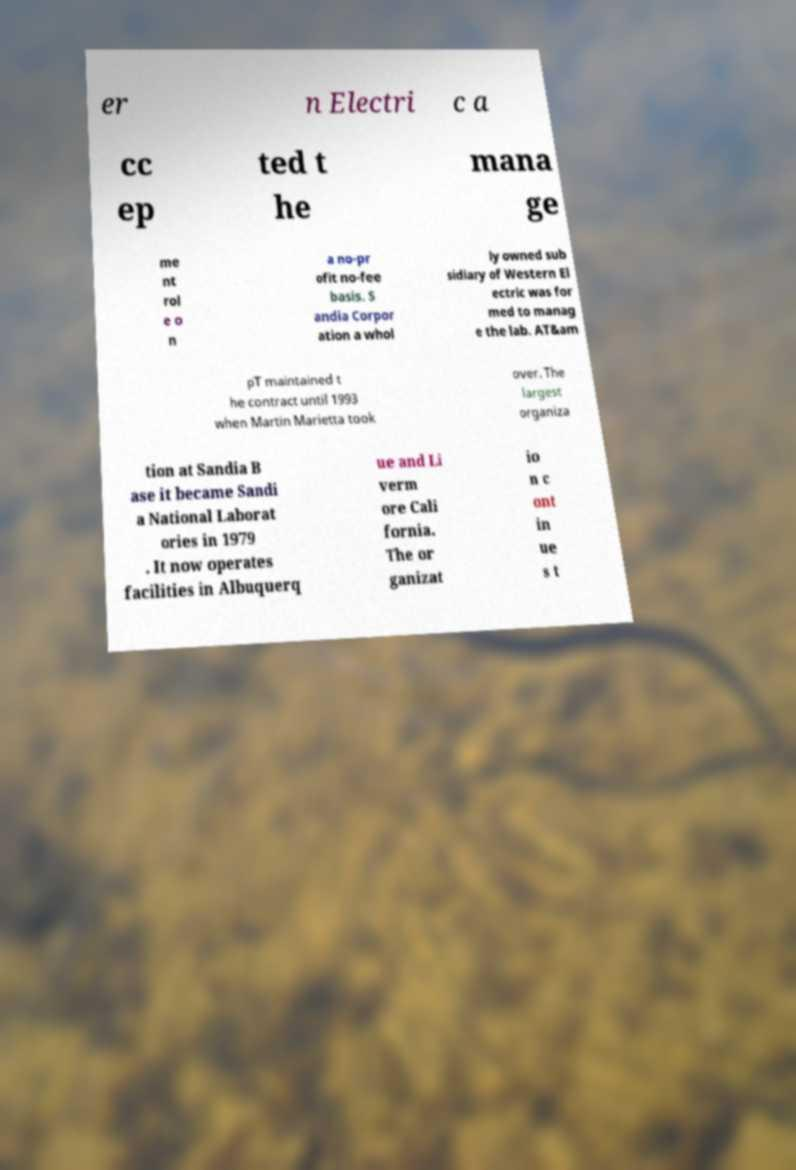For documentation purposes, I need the text within this image transcribed. Could you provide that? er n Electri c a cc ep ted t he mana ge me nt rol e o n a no-pr ofit no-fee basis. S andia Corpor ation a whol ly owned sub sidiary of Western El ectric was for med to manag e the lab. AT&am pT maintained t he contract until 1993 when Martin Marietta took over. The largest organiza tion at Sandia B ase it became Sandi a National Laborat ories in 1979 . It now operates facilities in Albuquerq ue and Li verm ore Cali fornia. The or ganizat io n c ont in ue s t 